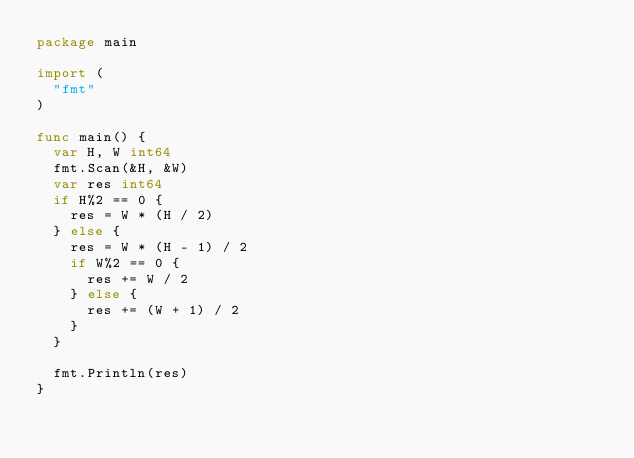Convert code to text. <code><loc_0><loc_0><loc_500><loc_500><_Go_>package main

import (
	"fmt"
)

func main() {
	var H, W int64
	fmt.Scan(&H, &W)
	var res int64
	if H%2 == 0 {
		res = W * (H / 2)
	} else {
		res = W * (H - 1) / 2
		if W%2 == 0 {
			res += W / 2
		} else {
			res += (W + 1) / 2
		}
	}

	fmt.Println(res)
}
</code> 